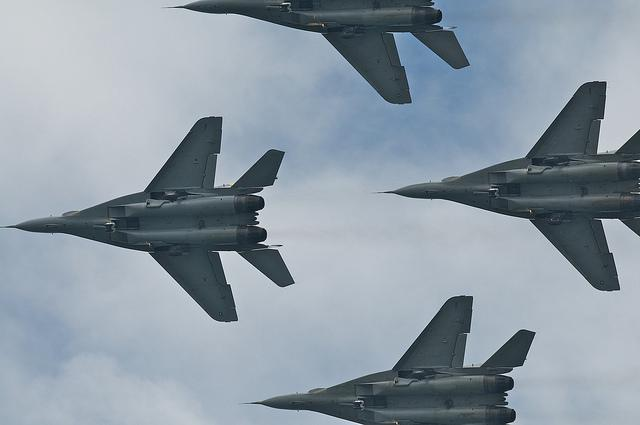The number of items visible in the sky cane be referred to as what? Please explain your reasoning. quartet. Four planes make up a quartet. 